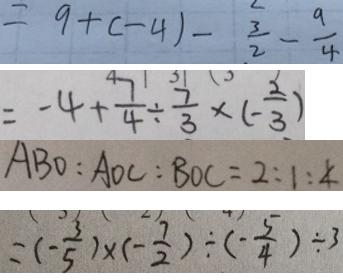Convert formula to latex. <formula><loc_0><loc_0><loc_500><loc_500>= 9 + ( - 4 ) - \frac { 3 } { 2 } - \frac { 9 } { 4 } 
 = - 4 + \frac { 7 } { 4 } \div \frac { 7 } { 3 } \times ( - \frac { 2 } { 3 } ) 
 A B O : A O C : B O C = 2 : 1 : 4 
 = ( - \frac { 3 } { 5 } ) \times ( - \frac { 7 } { 2 } ) \div ( - \frac { 5 } { 4 } ) \div 3</formula> 